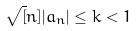Convert formula to latex. <formula><loc_0><loc_0><loc_500><loc_500>\sqrt { [ } n ] { | a _ { n } | } \leq k < 1</formula> 